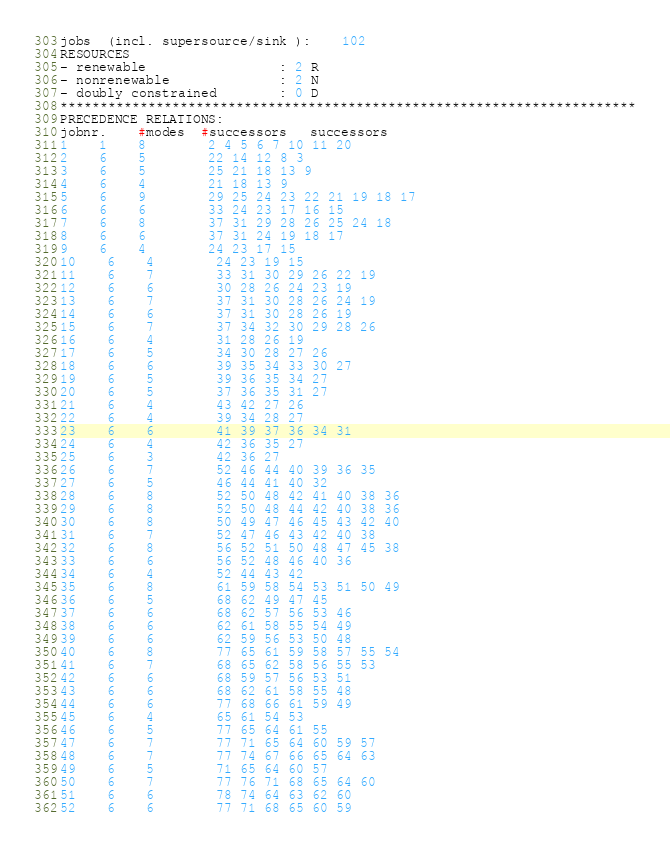<code> <loc_0><loc_0><loc_500><loc_500><_ObjectiveC_>jobs  (incl. supersource/sink ):	102
RESOURCES
- renewable                 : 2 R
- nonrenewable              : 2 N
- doubly constrained        : 0 D
************************************************************************
PRECEDENCE RELATIONS:
jobnr.    #modes  #successors   successors
1	1	8		2 4 5 6 7 10 11 20 
2	6	5		22 14 12 8 3 
3	6	5		25 21 18 13 9 
4	6	4		21 18 13 9 
5	6	9		29 25 24 23 22 21 19 18 17 
6	6	6		33 24 23 17 16 15 
7	6	8		37 31 29 28 26 25 24 18 
8	6	6		37 31 24 19 18 17 
9	6	4		24 23 17 15 
10	6	4		24 23 19 15 
11	6	7		33 31 30 29 26 22 19 
12	6	6		30 28 26 24 23 19 
13	6	7		37 31 30 28 26 24 19 
14	6	6		37 31 30 28 26 19 
15	6	7		37 34 32 30 29 28 26 
16	6	4		31 28 26 19 
17	6	5		34 30 28 27 26 
18	6	6		39 35 34 33 30 27 
19	6	5		39 36 35 34 27 
20	6	5		37 36 35 31 27 
21	6	4		43 42 27 26 
22	6	4		39 34 28 27 
23	6	6		41 39 37 36 34 31 
24	6	4		42 36 35 27 
25	6	3		42 36 27 
26	6	7		52 46 44 40 39 36 35 
27	6	5		46 44 41 40 32 
28	6	8		52 50 48 42 41 40 38 36 
29	6	8		52 50 48 44 42 40 38 36 
30	6	8		50 49 47 46 45 43 42 40 
31	6	7		52 47 46 43 42 40 38 
32	6	8		56 52 51 50 48 47 45 38 
33	6	6		56 52 48 46 40 36 
34	6	4		52 44 43 42 
35	6	8		61 59 58 54 53 51 50 49 
36	6	5		68 62 49 47 45 
37	6	6		68 62 57 56 53 46 
38	6	6		62 61 58 55 54 49 
39	6	6		62 59 56 53 50 48 
40	6	8		77 65 61 59 58 57 55 54 
41	6	7		68 65 62 58 56 55 53 
42	6	6		68 59 57 56 53 51 
43	6	6		68 62 61 58 55 48 
44	6	6		77 68 66 61 59 49 
45	6	4		65 61 54 53 
46	6	5		77 65 64 61 55 
47	6	7		77 71 65 64 60 59 57 
48	6	7		77 74 67 66 65 64 63 
49	6	5		71 65 64 60 57 
50	6	7		77 76 71 68 65 64 60 
51	6	6		78 74 64 63 62 60 
52	6	6		77 71 68 65 60 59 </code> 